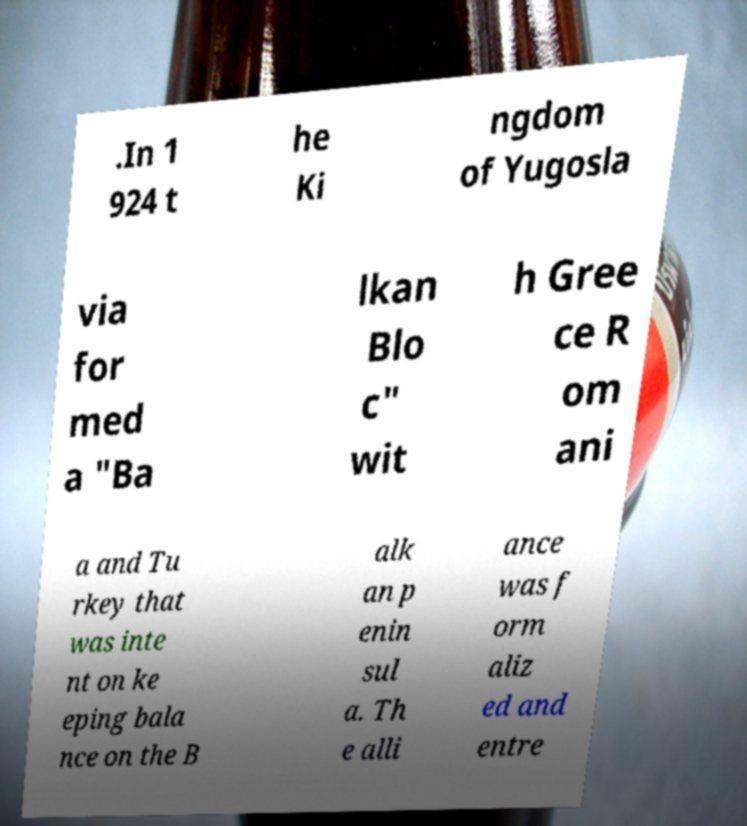Can you read and provide the text displayed in the image?This photo seems to have some interesting text. Can you extract and type it out for me? .In 1 924 t he Ki ngdom of Yugosla via for med a "Ba lkan Blo c" wit h Gree ce R om ani a and Tu rkey that was inte nt on ke eping bala nce on the B alk an p enin sul a. Th e alli ance was f orm aliz ed and entre 